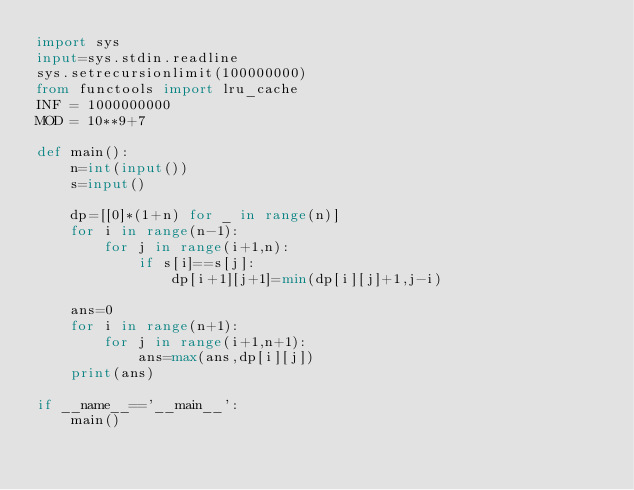Convert code to text. <code><loc_0><loc_0><loc_500><loc_500><_Python_>import sys
input=sys.stdin.readline   
sys.setrecursionlimit(100000000)
from functools import lru_cache
INF = 1000000000
MOD = 10**9+7

def main():
    n=int(input())
    s=input()

    dp=[[0]*(1+n) for _ in range(n)]
    for i in range(n-1):
        for j in range(i+1,n):
            if s[i]==s[j]:
                dp[i+1][j+1]=min(dp[i][j]+1,j-i)          
    
    ans=0
    for i in range(n+1):
        for j in range(i+1,n+1):
            ans=max(ans,dp[i][j])
    print(ans)

if __name__=='__main__':
    main()</code> 